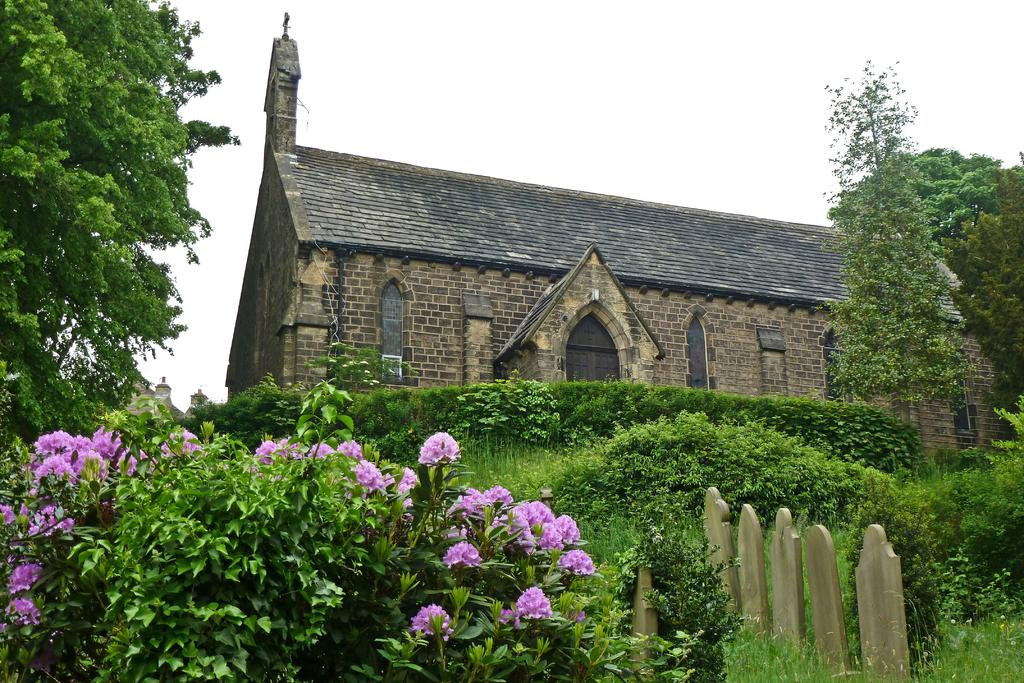What type of vegetation can be seen in the image? There are plants, flowers, and trees in the image. What type of structure is present in the image? There is a house in the image. What might be used as decorative elements in the image? There are objects that resemble stones in the image. What is visible in the background of the image? The sky is visible in the background of the image. Can you tell me where the beggar is standing in the image? There is no beggar present in the image. What advice would the uncle give to the plants in the image? There is no uncle present in the image, and therefore no advice can be given to the plants. 